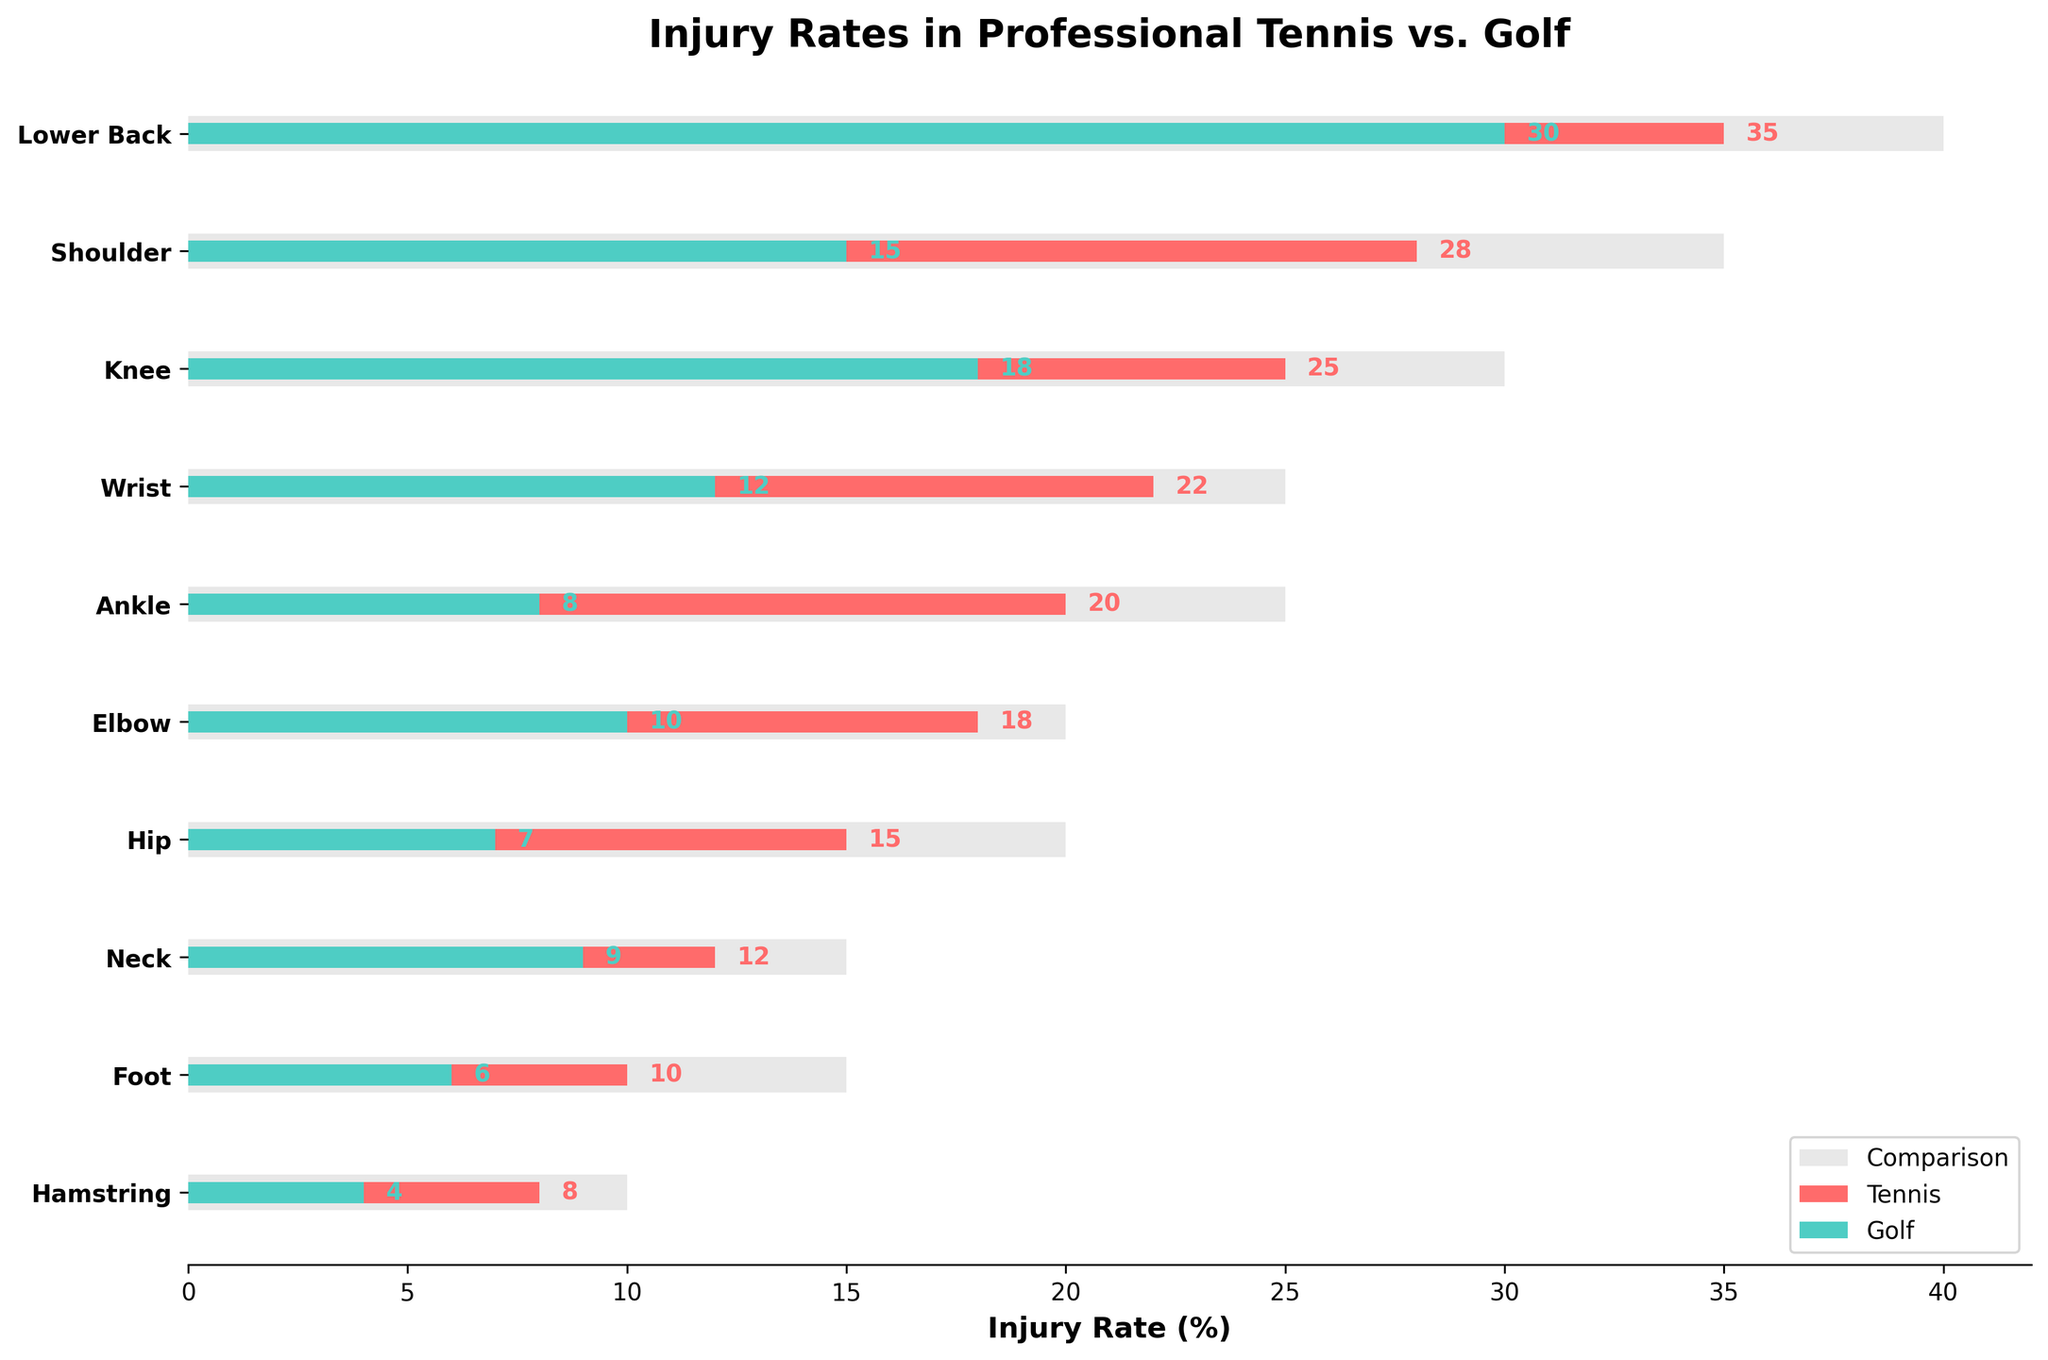How many categories of body parts are displayed? There are 10 categories listed on the y-axis representing different body parts.
Answer: 10 What is the title of the chart? The title is displayed at the top of the chart, and it reads "Injury Rates in Professional Tennis vs. Golf."
Answer: Injury Rates in Professional Tennis vs. Golf Which category shows the highest injury rate for tennis players? By looking at the red bars for tennis, the "Lower Back" category has the highest value at 35%.
Answer: Lower Back Which injury has a higher rate in tennis than in golf by more than 20%? Checking both red and green bars, the "Shoulder" category shows tennis at 28% and golf at 15%, which is a difference of 13%. The "Ankle" category is 20% for tennis and 8% for golf, a difference of 12%. None of the categories show a difference over 20%.
Answer: None In which category is the injury rate for golf closest to that of the comparison value? Looking at the green and grey bars, the category "Neck" has a value of 9% for golf and 15% for the comparison.
Answer: Neck What is the difference in injury rates between tennis and golf for the Knee category? The difference is calculated by subtracting the value for golf from the value for tennis: 25% - 18% = 7%.
Answer: 7% Which body part has an injury rate of 10% in tennis? By examining the red bars and their values, the "Elbow" category has an injury rate of 10%.
Answer: Elbow How many categories show a higher injury rate for tennis than for golf? By comparing each pair of bars, categories where tennis has a higher rate than golf include Lower Back, Shoulder, Knee, Wrist, Ankle, Elbow, Hip, Foot, and Hamstring, totaling nine categories.
Answer: 9 For which category is the injury rate in tennis exactly double that in golf? Looking at the bars' values, none of the categories have the tennis injury rate exactly double the golf injury rate.
Answer: None Which category has the smallest difference in injury rates between tennis and golf? By comparing the bars, the "Neck" category has the smallest difference, with tennis at 12% and golf at 9%, a 3% difference.
Answer: Neck 